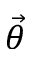Convert formula to latex. <formula><loc_0><loc_0><loc_500><loc_500>\vec { \theta }</formula> 